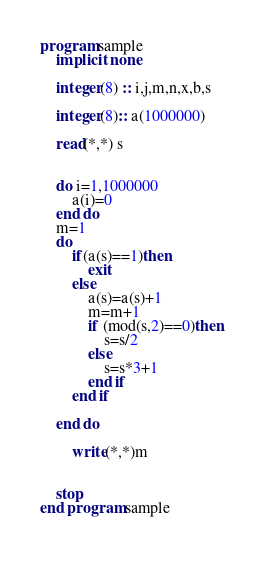Convert code to text. <code><loc_0><loc_0><loc_500><loc_500><_FORTRAN_>program sample
    implicit none
  
    integer(8) :: i,j,m,n,x,b,s
    
    integer(8):: a(1000000)
  
    read(*,*) s
    
    
    do i=1,1000000
        a(i)=0
    end do
    m=1
    do 
        if(a(s)==1)then
            exit
        else
            a(s)=a(s)+1
            m=m+1
            if (mod(s,2)==0)then
                s=s/2
            else
                s=s*3+1
            end if
        end if
                 
    end do
   
        write(*,*)m
   
    
    stop
end program sample
  

</code> 